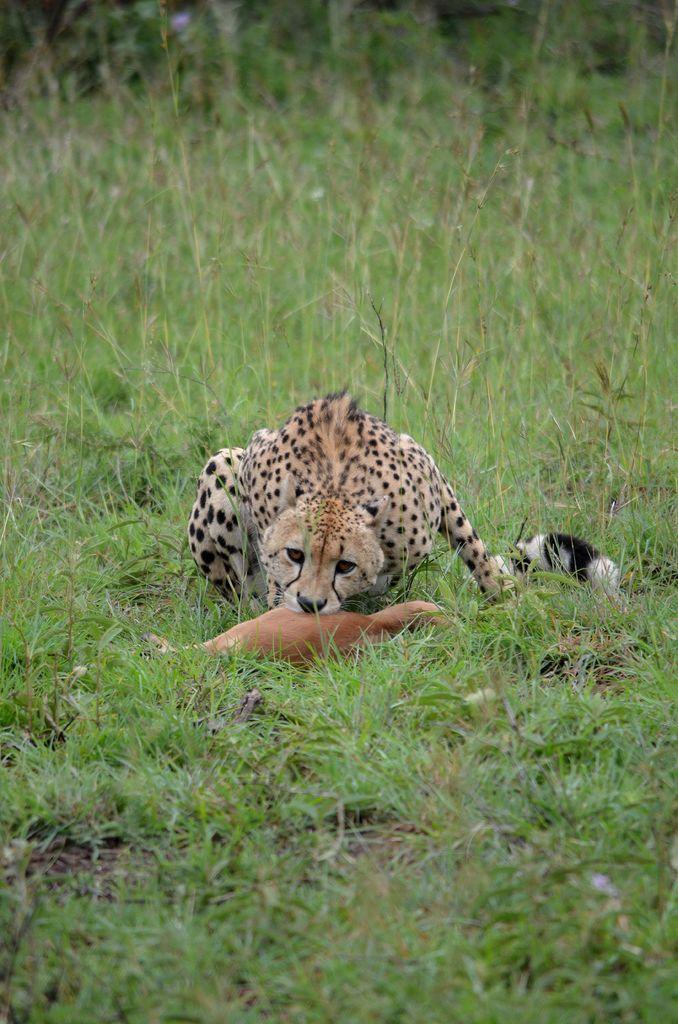Please provide a concise description of this image. In the image there is a cheetah eating a deer on the grassland. 